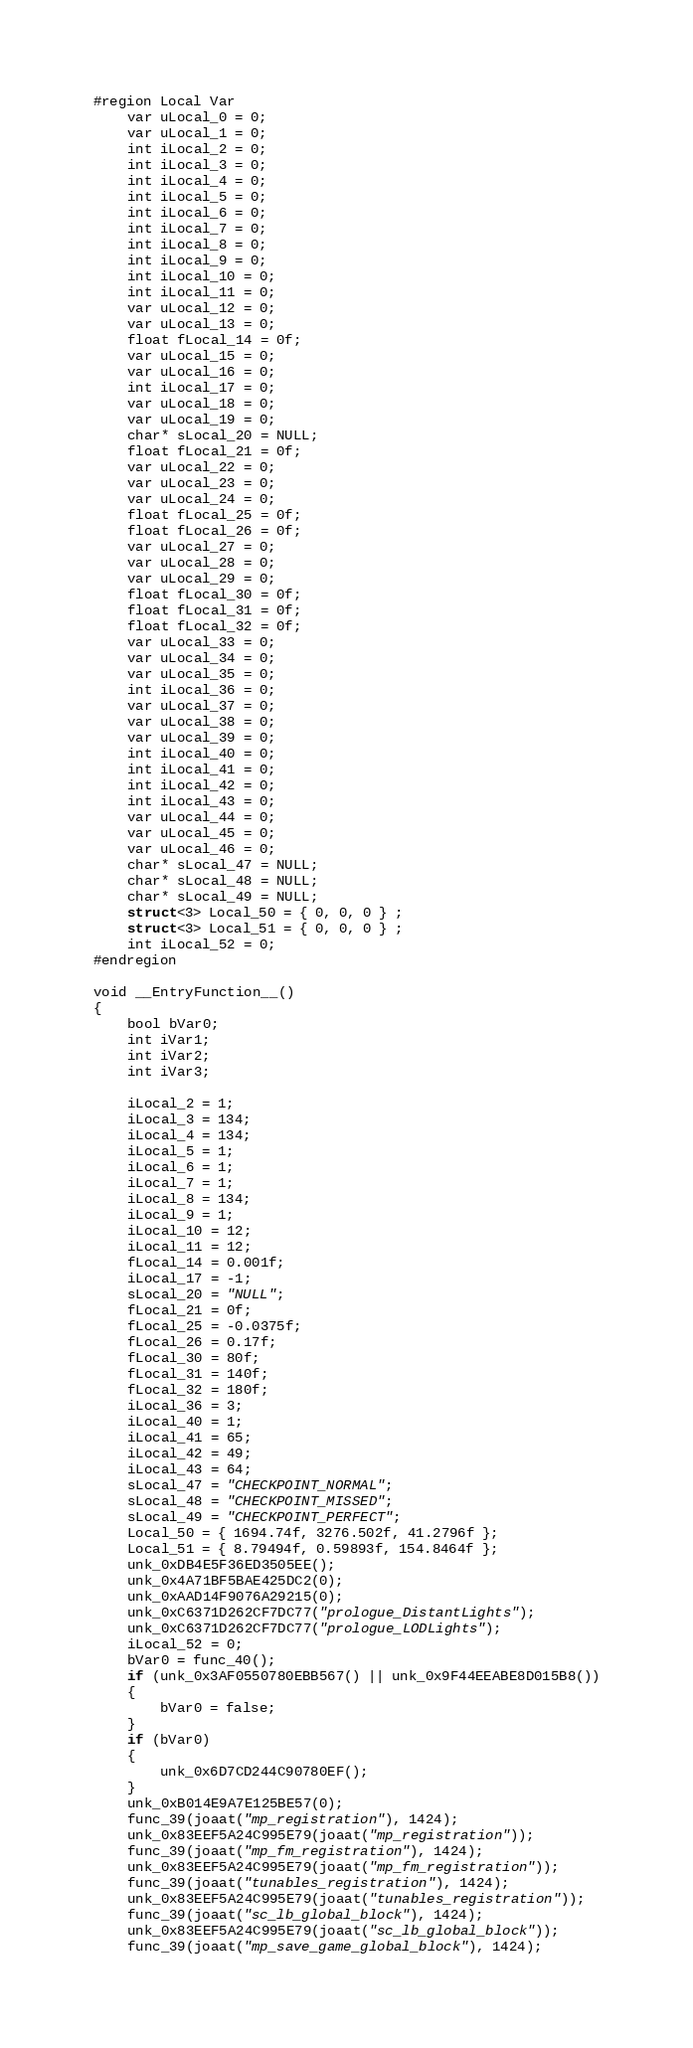Convert code to text. <code><loc_0><loc_0><loc_500><loc_500><_C_>#region Local Var
	var uLocal_0 = 0;
	var uLocal_1 = 0;
	int iLocal_2 = 0;
	int iLocal_3 = 0;
	int iLocal_4 = 0;
	int iLocal_5 = 0;
	int iLocal_6 = 0;
	int iLocal_7 = 0;
	int iLocal_8 = 0;
	int iLocal_9 = 0;
	int iLocal_10 = 0;
	int iLocal_11 = 0;
	var uLocal_12 = 0;
	var uLocal_13 = 0;
	float fLocal_14 = 0f;
	var uLocal_15 = 0;
	var uLocal_16 = 0;
	int iLocal_17 = 0;
	var uLocal_18 = 0;
	var uLocal_19 = 0;
	char* sLocal_20 = NULL;
	float fLocal_21 = 0f;
	var uLocal_22 = 0;
	var uLocal_23 = 0;
	var uLocal_24 = 0;
	float fLocal_25 = 0f;
	float fLocal_26 = 0f;
	var uLocal_27 = 0;
	var uLocal_28 = 0;
	var uLocal_29 = 0;
	float fLocal_30 = 0f;
	float fLocal_31 = 0f;
	float fLocal_32 = 0f;
	var uLocal_33 = 0;
	var uLocal_34 = 0;
	var uLocal_35 = 0;
	int iLocal_36 = 0;
	var uLocal_37 = 0;
	var uLocal_38 = 0;
	var uLocal_39 = 0;
	int iLocal_40 = 0;
	int iLocal_41 = 0;
	int iLocal_42 = 0;
	int iLocal_43 = 0;
	var uLocal_44 = 0;
	var uLocal_45 = 0;
	var uLocal_46 = 0;
	char* sLocal_47 = NULL;
	char* sLocal_48 = NULL;
	char* sLocal_49 = NULL;
	struct<3> Local_50 = { 0, 0, 0 } ;
	struct<3> Local_51 = { 0, 0, 0 } ;
	int iLocal_52 = 0;
#endregion

void __EntryFunction__()
{
	bool bVar0;
	int iVar1;
	int iVar2;
	int iVar3;
	
	iLocal_2 = 1;
	iLocal_3 = 134;
	iLocal_4 = 134;
	iLocal_5 = 1;
	iLocal_6 = 1;
	iLocal_7 = 1;
	iLocal_8 = 134;
	iLocal_9 = 1;
	iLocal_10 = 12;
	iLocal_11 = 12;
	fLocal_14 = 0.001f;
	iLocal_17 = -1;
	sLocal_20 = "NULL";
	fLocal_21 = 0f;
	fLocal_25 = -0.0375f;
	fLocal_26 = 0.17f;
	fLocal_30 = 80f;
	fLocal_31 = 140f;
	fLocal_32 = 180f;
	iLocal_36 = 3;
	iLocal_40 = 1;
	iLocal_41 = 65;
	iLocal_42 = 49;
	iLocal_43 = 64;
	sLocal_47 = "CHECKPOINT_NORMAL";
	sLocal_48 = "CHECKPOINT_MISSED";
	sLocal_49 = "CHECKPOINT_PERFECT";
	Local_50 = { 1694.74f, 3276.502f, 41.2796f };
	Local_51 = { 8.79494f, 0.59893f, 154.8464f };
	unk_0xDB4E5F36ED3505EE();
	unk_0x4A71BF5BAE425DC2(0);
	unk_0xAAD14F9076A29215(0);
	unk_0xC6371D262CF7DC77("prologue_DistantLights");
	unk_0xC6371D262CF7DC77("prologue_LODLights");
	iLocal_52 = 0;
	bVar0 = func_40();
	if (unk_0x3AF0550780EBB567() || unk_0x9F44EEABE8D015B8())
	{
		bVar0 = false;
	}
	if (bVar0)
	{
		unk_0x6D7CD244C90780EF();
	}
	unk_0xB014E9A7E125BE57(0);
	func_39(joaat("mp_registration"), 1424);
	unk_0x83EEF5A24C995E79(joaat("mp_registration"));
	func_39(joaat("mp_fm_registration"), 1424);
	unk_0x83EEF5A24C995E79(joaat("mp_fm_registration"));
	func_39(joaat("tunables_registration"), 1424);
	unk_0x83EEF5A24C995E79(joaat("tunables_registration"));
	func_39(joaat("sc_lb_global_block"), 1424);
	unk_0x83EEF5A24C995E79(joaat("sc_lb_global_block"));
	func_39(joaat("mp_save_game_global_block"), 1424);</code> 